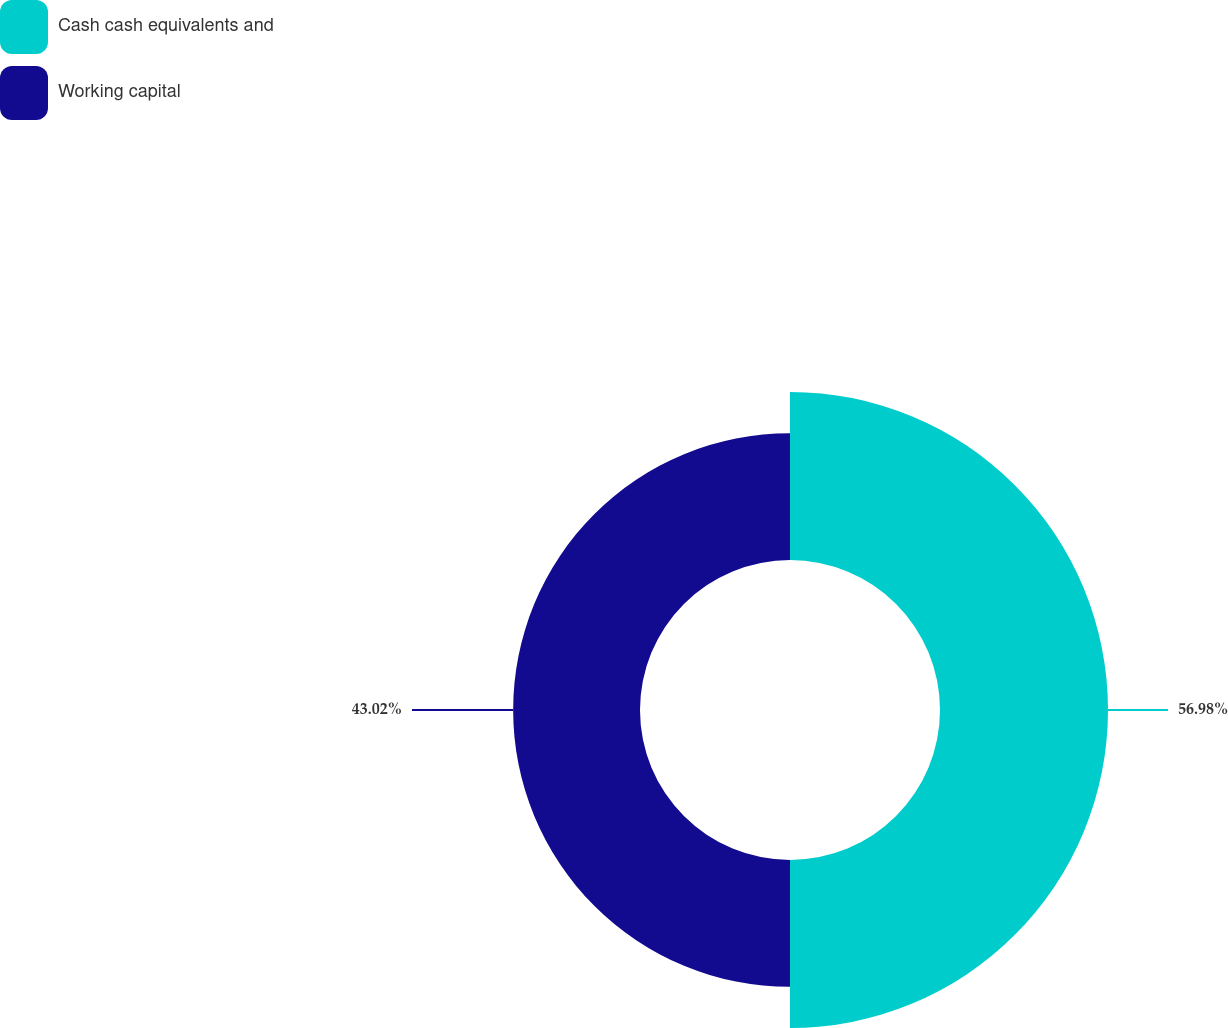Convert chart to OTSL. <chart><loc_0><loc_0><loc_500><loc_500><pie_chart><fcel>Cash cash equivalents and<fcel>Working capital<nl><fcel>56.98%<fcel>43.02%<nl></chart> 